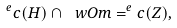<formula> <loc_0><loc_0><loc_500><loc_500>^ { e } c ( H ) \cap \ w O m = ^ { e } c ( Z ) ,</formula> 